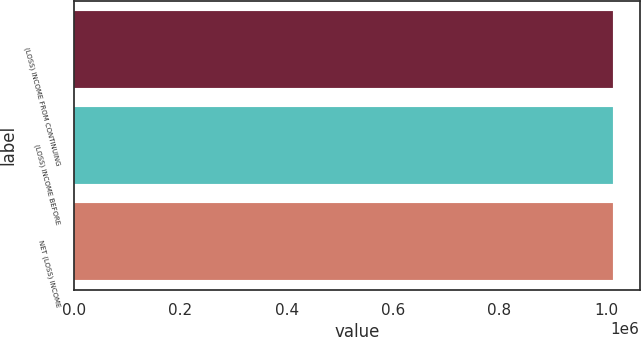Convert chart. <chart><loc_0><loc_0><loc_500><loc_500><bar_chart><fcel>(LOSS) INCOME FROM CONTINUING<fcel>(LOSS) INCOME BEFORE<fcel>NET (LOSS) INCOME<nl><fcel>1.01263e+06<fcel>1.01263e+06<fcel>1.01263e+06<nl></chart> 